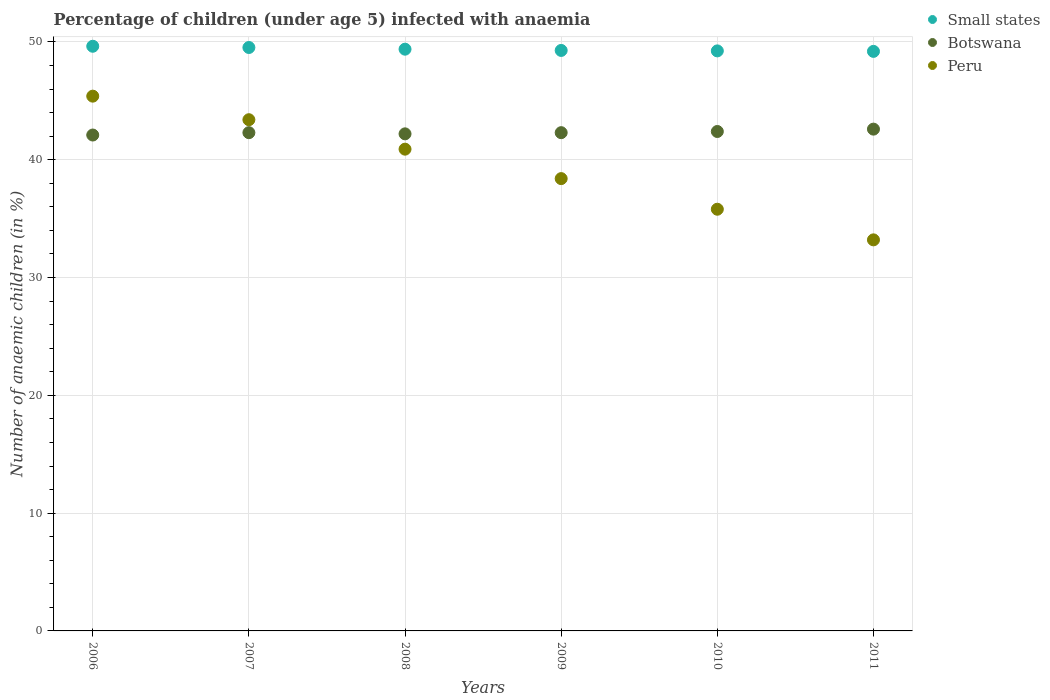What is the percentage of children infected with anaemia in in Small states in 2010?
Your answer should be compact. 49.24. Across all years, what is the maximum percentage of children infected with anaemia in in Botswana?
Ensure brevity in your answer.  42.6. Across all years, what is the minimum percentage of children infected with anaemia in in Botswana?
Your answer should be compact. 42.1. In which year was the percentage of children infected with anaemia in in Small states maximum?
Keep it short and to the point. 2006. In which year was the percentage of children infected with anaemia in in Botswana minimum?
Make the answer very short. 2006. What is the total percentage of children infected with anaemia in in Small states in the graph?
Keep it short and to the point. 296.28. What is the difference between the percentage of children infected with anaemia in in Peru in 2008 and the percentage of children infected with anaemia in in Small states in 2010?
Provide a short and direct response. -8.34. What is the average percentage of children infected with anaemia in in Small states per year?
Ensure brevity in your answer.  49.38. In the year 2007, what is the difference between the percentage of children infected with anaemia in in Small states and percentage of children infected with anaemia in in Botswana?
Provide a succinct answer. 7.23. In how many years, is the percentage of children infected with anaemia in in Small states greater than 40 %?
Make the answer very short. 6. What is the ratio of the percentage of children infected with anaemia in in Small states in 2007 to that in 2009?
Your answer should be very brief. 1.01. What is the difference between the highest and the second highest percentage of children infected with anaemia in in Small states?
Make the answer very short. 0.11. What is the difference between the highest and the lowest percentage of children infected with anaemia in in Peru?
Your answer should be very brief. 12.2. In how many years, is the percentage of children infected with anaemia in in Peru greater than the average percentage of children infected with anaemia in in Peru taken over all years?
Offer a terse response. 3. Is the sum of the percentage of children infected with anaemia in in Peru in 2006 and 2011 greater than the maximum percentage of children infected with anaemia in in Botswana across all years?
Provide a short and direct response. Yes. Does the percentage of children infected with anaemia in in Peru monotonically increase over the years?
Ensure brevity in your answer.  No. Is the percentage of children infected with anaemia in in Small states strictly greater than the percentage of children infected with anaemia in in Peru over the years?
Provide a succinct answer. Yes. Is the percentage of children infected with anaemia in in Small states strictly less than the percentage of children infected with anaemia in in Peru over the years?
Ensure brevity in your answer.  No. What is the difference between two consecutive major ticks on the Y-axis?
Keep it short and to the point. 10. Are the values on the major ticks of Y-axis written in scientific E-notation?
Your answer should be compact. No. Does the graph contain any zero values?
Offer a terse response. No. Where does the legend appear in the graph?
Provide a short and direct response. Top right. How many legend labels are there?
Keep it short and to the point. 3. How are the legend labels stacked?
Offer a terse response. Vertical. What is the title of the graph?
Your answer should be very brief. Percentage of children (under age 5) infected with anaemia. What is the label or title of the Y-axis?
Make the answer very short. Number of anaemic children (in %). What is the Number of anaemic children (in %) of Small states in 2006?
Your answer should be very brief. 49.64. What is the Number of anaemic children (in %) of Botswana in 2006?
Offer a very short reply. 42.1. What is the Number of anaemic children (in %) of Peru in 2006?
Offer a very short reply. 45.4. What is the Number of anaemic children (in %) in Small states in 2007?
Your answer should be very brief. 49.53. What is the Number of anaemic children (in %) in Botswana in 2007?
Provide a short and direct response. 42.3. What is the Number of anaemic children (in %) of Peru in 2007?
Provide a short and direct response. 43.4. What is the Number of anaemic children (in %) in Small states in 2008?
Make the answer very short. 49.39. What is the Number of anaemic children (in %) of Botswana in 2008?
Offer a terse response. 42.2. What is the Number of anaemic children (in %) of Peru in 2008?
Ensure brevity in your answer.  40.9. What is the Number of anaemic children (in %) of Small states in 2009?
Give a very brief answer. 49.28. What is the Number of anaemic children (in %) in Botswana in 2009?
Provide a succinct answer. 42.3. What is the Number of anaemic children (in %) in Peru in 2009?
Your answer should be very brief. 38.4. What is the Number of anaemic children (in %) of Small states in 2010?
Ensure brevity in your answer.  49.24. What is the Number of anaemic children (in %) in Botswana in 2010?
Your answer should be very brief. 42.4. What is the Number of anaemic children (in %) of Peru in 2010?
Provide a succinct answer. 35.8. What is the Number of anaemic children (in %) in Small states in 2011?
Your answer should be compact. 49.2. What is the Number of anaemic children (in %) in Botswana in 2011?
Offer a terse response. 42.6. What is the Number of anaemic children (in %) of Peru in 2011?
Give a very brief answer. 33.2. Across all years, what is the maximum Number of anaemic children (in %) in Small states?
Your answer should be compact. 49.64. Across all years, what is the maximum Number of anaemic children (in %) of Botswana?
Ensure brevity in your answer.  42.6. Across all years, what is the maximum Number of anaemic children (in %) in Peru?
Provide a short and direct response. 45.4. Across all years, what is the minimum Number of anaemic children (in %) in Small states?
Your response must be concise. 49.2. Across all years, what is the minimum Number of anaemic children (in %) in Botswana?
Give a very brief answer. 42.1. Across all years, what is the minimum Number of anaemic children (in %) in Peru?
Make the answer very short. 33.2. What is the total Number of anaemic children (in %) in Small states in the graph?
Your answer should be very brief. 296.28. What is the total Number of anaemic children (in %) of Botswana in the graph?
Ensure brevity in your answer.  253.9. What is the total Number of anaemic children (in %) in Peru in the graph?
Offer a very short reply. 237.1. What is the difference between the Number of anaemic children (in %) in Small states in 2006 and that in 2007?
Your answer should be compact. 0.11. What is the difference between the Number of anaemic children (in %) in Small states in 2006 and that in 2008?
Your response must be concise. 0.25. What is the difference between the Number of anaemic children (in %) of Botswana in 2006 and that in 2008?
Make the answer very short. -0.1. What is the difference between the Number of anaemic children (in %) in Peru in 2006 and that in 2008?
Make the answer very short. 4.5. What is the difference between the Number of anaemic children (in %) of Small states in 2006 and that in 2009?
Keep it short and to the point. 0.36. What is the difference between the Number of anaemic children (in %) in Botswana in 2006 and that in 2009?
Your answer should be very brief. -0.2. What is the difference between the Number of anaemic children (in %) in Peru in 2006 and that in 2009?
Your answer should be very brief. 7. What is the difference between the Number of anaemic children (in %) in Small states in 2006 and that in 2010?
Offer a terse response. 0.39. What is the difference between the Number of anaemic children (in %) in Peru in 2006 and that in 2010?
Give a very brief answer. 9.6. What is the difference between the Number of anaemic children (in %) in Small states in 2006 and that in 2011?
Your response must be concise. 0.44. What is the difference between the Number of anaemic children (in %) of Botswana in 2006 and that in 2011?
Provide a succinct answer. -0.5. What is the difference between the Number of anaemic children (in %) in Small states in 2007 and that in 2008?
Your answer should be very brief. 0.14. What is the difference between the Number of anaemic children (in %) of Peru in 2007 and that in 2008?
Keep it short and to the point. 2.5. What is the difference between the Number of anaemic children (in %) in Small states in 2007 and that in 2009?
Ensure brevity in your answer.  0.25. What is the difference between the Number of anaemic children (in %) in Small states in 2007 and that in 2010?
Offer a terse response. 0.29. What is the difference between the Number of anaemic children (in %) of Botswana in 2007 and that in 2010?
Make the answer very short. -0.1. What is the difference between the Number of anaemic children (in %) in Peru in 2007 and that in 2010?
Ensure brevity in your answer.  7.6. What is the difference between the Number of anaemic children (in %) in Small states in 2007 and that in 2011?
Give a very brief answer. 0.33. What is the difference between the Number of anaemic children (in %) of Botswana in 2007 and that in 2011?
Keep it short and to the point. -0.3. What is the difference between the Number of anaemic children (in %) of Small states in 2008 and that in 2009?
Provide a succinct answer. 0.11. What is the difference between the Number of anaemic children (in %) of Botswana in 2008 and that in 2009?
Provide a succinct answer. -0.1. What is the difference between the Number of anaemic children (in %) in Small states in 2008 and that in 2010?
Offer a terse response. 0.15. What is the difference between the Number of anaemic children (in %) of Botswana in 2008 and that in 2010?
Your answer should be compact. -0.2. What is the difference between the Number of anaemic children (in %) of Small states in 2008 and that in 2011?
Offer a terse response. 0.19. What is the difference between the Number of anaemic children (in %) in Botswana in 2008 and that in 2011?
Offer a very short reply. -0.4. What is the difference between the Number of anaemic children (in %) in Small states in 2009 and that in 2010?
Keep it short and to the point. 0.04. What is the difference between the Number of anaemic children (in %) in Small states in 2009 and that in 2011?
Make the answer very short. 0.08. What is the difference between the Number of anaemic children (in %) of Small states in 2010 and that in 2011?
Offer a very short reply. 0.04. What is the difference between the Number of anaemic children (in %) of Botswana in 2010 and that in 2011?
Give a very brief answer. -0.2. What is the difference between the Number of anaemic children (in %) of Small states in 2006 and the Number of anaemic children (in %) of Botswana in 2007?
Provide a succinct answer. 7.34. What is the difference between the Number of anaemic children (in %) of Small states in 2006 and the Number of anaemic children (in %) of Peru in 2007?
Give a very brief answer. 6.24. What is the difference between the Number of anaemic children (in %) of Small states in 2006 and the Number of anaemic children (in %) of Botswana in 2008?
Provide a short and direct response. 7.44. What is the difference between the Number of anaemic children (in %) of Small states in 2006 and the Number of anaemic children (in %) of Peru in 2008?
Give a very brief answer. 8.74. What is the difference between the Number of anaemic children (in %) of Small states in 2006 and the Number of anaemic children (in %) of Botswana in 2009?
Your response must be concise. 7.34. What is the difference between the Number of anaemic children (in %) of Small states in 2006 and the Number of anaemic children (in %) of Peru in 2009?
Keep it short and to the point. 11.24. What is the difference between the Number of anaemic children (in %) of Small states in 2006 and the Number of anaemic children (in %) of Botswana in 2010?
Give a very brief answer. 7.24. What is the difference between the Number of anaemic children (in %) of Small states in 2006 and the Number of anaemic children (in %) of Peru in 2010?
Make the answer very short. 13.84. What is the difference between the Number of anaemic children (in %) of Botswana in 2006 and the Number of anaemic children (in %) of Peru in 2010?
Your response must be concise. 6.3. What is the difference between the Number of anaemic children (in %) in Small states in 2006 and the Number of anaemic children (in %) in Botswana in 2011?
Keep it short and to the point. 7.04. What is the difference between the Number of anaemic children (in %) of Small states in 2006 and the Number of anaemic children (in %) of Peru in 2011?
Make the answer very short. 16.44. What is the difference between the Number of anaemic children (in %) in Botswana in 2006 and the Number of anaemic children (in %) in Peru in 2011?
Provide a short and direct response. 8.9. What is the difference between the Number of anaemic children (in %) in Small states in 2007 and the Number of anaemic children (in %) in Botswana in 2008?
Your answer should be compact. 7.33. What is the difference between the Number of anaemic children (in %) of Small states in 2007 and the Number of anaemic children (in %) of Peru in 2008?
Offer a terse response. 8.63. What is the difference between the Number of anaemic children (in %) of Botswana in 2007 and the Number of anaemic children (in %) of Peru in 2008?
Ensure brevity in your answer.  1.4. What is the difference between the Number of anaemic children (in %) of Small states in 2007 and the Number of anaemic children (in %) of Botswana in 2009?
Your answer should be very brief. 7.23. What is the difference between the Number of anaemic children (in %) of Small states in 2007 and the Number of anaemic children (in %) of Peru in 2009?
Make the answer very short. 11.13. What is the difference between the Number of anaemic children (in %) in Small states in 2007 and the Number of anaemic children (in %) in Botswana in 2010?
Make the answer very short. 7.13. What is the difference between the Number of anaemic children (in %) of Small states in 2007 and the Number of anaemic children (in %) of Peru in 2010?
Make the answer very short. 13.73. What is the difference between the Number of anaemic children (in %) in Small states in 2007 and the Number of anaemic children (in %) in Botswana in 2011?
Your response must be concise. 6.93. What is the difference between the Number of anaemic children (in %) of Small states in 2007 and the Number of anaemic children (in %) of Peru in 2011?
Your answer should be compact. 16.33. What is the difference between the Number of anaemic children (in %) of Botswana in 2007 and the Number of anaemic children (in %) of Peru in 2011?
Your answer should be compact. 9.1. What is the difference between the Number of anaemic children (in %) in Small states in 2008 and the Number of anaemic children (in %) in Botswana in 2009?
Keep it short and to the point. 7.09. What is the difference between the Number of anaemic children (in %) in Small states in 2008 and the Number of anaemic children (in %) in Peru in 2009?
Your answer should be very brief. 10.99. What is the difference between the Number of anaemic children (in %) of Small states in 2008 and the Number of anaemic children (in %) of Botswana in 2010?
Your answer should be compact. 6.99. What is the difference between the Number of anaemic children (in %) of Small states in 2008 and the Number of anaemic children (in %) of Peru in 2010?
Make the answer very short. 13.59. What is the difference between the Number of anaemic children (in %) in Botswana in 2008 and the Number of anaemic children (in %) in Peru in 2010?
Provide a succinct answer. 6.4. What is the difference between the Number of anaemic children (in %) in Small states in 2008 and the Number of anaemic children (in %) in Botswana in 2011?
Provide a succinct answer. 6.79. What is the difference between the Number of anaemic children (in %) in Small states in 2008 and the Number of anaemic children (in %) in Peru in 2011?
Provide a short and direct response. 16.19. What is the difference between the Number of anaemic children (in %) in Botswana in 2008 and the Number of anaemic children (in %) in Peru in 2011?
Give a very brief answer. 9. What is the difference between the Number of anaemic children (in %) of Small states in 2009 and the Number of anaemic children (in %) of Botswana in 2010?
Offer a terse response. 6.88. What is the difference between the Number of anaemic children (in %) in Small states in 2009 and the Number of anaemic children (in %) in Peru in 2010?
Provide a succinct answer. 13.48. What is the difference between the Number of anaemic children (in %) of Botswana in 2009 and the Number of anaemic children (in %) of Peru in 2010?
Ensure brevity in your answer.  6.5. What is the difference between the Number of anaemic children (in %) in Small states in 2009 and the Number of anaemic children (in %) in Botswana in 2011?
Provide a succinct answer. 6.68. What is the difference between the Number of anaemic children (in %) in Small states in 2009 and the Number of anaemic children (in %) in Peru in 2011?
Keep it short and to the point. 16.08. What is the difference between the Number of anaemic children (in %) in Small states in 2010 and the Number of anaemic children (in %) in Botswana in 2011?
Keep it short and to the point. 6.64. What is the difference between the Number of anaemic children (in %) in Small states in 2010 and the Number of anaemic children (in %) in Peru in 2011?
Provide a short and direct response. 16.04. What is the average Number of anaemic children (in %) of Small states per year?
Make the answer very short. 49.38. What is the average Number of anaemic children (in %) of Botswana per year?
Keep it short and to the point. 42.32. What is the average Number of anaemic children (in %) in Peru per year?
Give a very brief answer. 39.52. In the year 2006, what is the difference between the Number of anaemic children (in %) of Small states and Number of anaemic children (in %) of Botswana?
Your answer should be very brief. 7.54. In the year 2006, what is the difference between the Number of anaemic children (in %) in Small states and Number of anaemic children (in %) in Peru?
Provide a short and direct response. 4.24. In the year 2006, what is the difference between the Number of anaemic children (in %) of Botswana and Number of anaemic children (in %) of Peru?
Offer a terse response. -3.3. In the year 2007, what is the difference between the Number of anaemic children (in %) in Small states and Number of anaemic children (in %) in Botswana?
Offer a very short reply. 7.23. In the year 2007, what is the difference between the Number of anaemic children (in %) of Small states and Number of anaemic children (in %) of Peru?
Offer a very short reply. 6.13. In the year 2007, what is the difference between the Number of anaemic children (in %) in Botswana and Number of anaemic children (in %) in Peru?
Provide a short and direct response. -1.1. In the year 2008, what is the difference between the Number of anaemic children (in %) of Small states and Number of anaemic children (in %) of Botswana?
Offer a terse response. 7.19. In the year 2008, what is the difference between the Number of anaemic children (in %) in Small states and Number of anaemic children (in %) in Peru?
Provide a succinct answer. 8.49. In the year 2009, what is the difference between the Number of anaemic children (in %) of Small states and Number of anaemic children (in %) of Botswana?
Offer a very short reply. 6.98. In the year 2009, what is the difference between the Number of anaemic children (in %) of Small states and Number of anaemic children (in %) of Peru?
Keep it short and to the point. 10.88. In the year 2010, what is the difference between the Number of anaemic children (in %) of Small states and Number of anaemic children (in %) of Botswana?
Offer a terse response. 6.84. In the year 2010, what is the difference between the Number of anaemic children (in %) of Small states and Number of anaemic children (in %) of Peru?
Provide a short and direct response. 13.44. In the year 2010, what is the difference between the Number of anaemic children (in %) of Botswana and Number of anaemic children (in %) of Peru?
Your response must be concise. 6.6. In the year 2011, what is the difference between the Number of anaemic children (in %) of Small states and Number of anaemic children (in %) of Botswana?
Your answer should be compact. 6.6. In the year 2011, what is the difference between the Number of anaemic children (in %) of Small states and Number of anaemic children (in %) of Peru?
Your answer should be very brief. 16. What is the ratio of the Number of anaemic children (in %) in Peru in 2006 to that in 2007?
Make the answer very short. 1.05. What is the ratio of the Number of anaemic children (in %) of Botswana in 2006 to that in 2008?
Ensure brevity in your answer.  1. What is the ratio of the Number of anaemic children (in %) in Peru in 2006 to that in 2008?
Offer a terse response. 1.11. What is the ratio of the Number of anaemic children (in %) in Botswana in 2006 to that in 2009?
Give a very brief answer. 1. What is the ratio of the Number of anaemic children (in %) in Peru in 2006 to that in 2009?
Offer a very short reply. 1.18. What is the ratio of the Number of anaemic children (in %) in Small states in 2006 to that in 2010?
Your answer should be very brief. 1.01. What is the ratio of the Number of anaemic children (in %) of Botswana in 2006 to that in 2010?
Your answer should be very brief. 0.99. What is the ratio of the Number of anaemic children (in %) in Peru in 2006 to that in 2010?
Your answer should be compact. 1.27. What is the ratio of the Number of anaemic children (in %) in Small states in 2006 to that in 2011?
Provide a short and direct response. 1.01. What is the ratio of the Number of anaemic children (in %) of Botswana in 2006 to that in 2011?
Your answer should be compact. 0.99. What is the ratio of the Number of anaemic children (in %) in Peru in 2006 to that in 2011?
Provide a short and direct response. 1.37. What is the ratio of the Number of anaemic children (in %) of Peru in 2007 to that in 2008?
Provide a succinct answer. 1.06. What is the ratio of the Number of anaemic children (in %) of Small states in 2007 to that in 2009?
Provide a short and direct response. 1.01. What is the ratio of the Number of anaemic children (in %) of Botswana in 2007 to that in 2009?
Your answer should be very brief. 1. What is the ratio of the Number of anaemic children (in %) in Peru in 2007 to that in 2009?
Keep it short and to the point. 1.13. What is the ratio of the Number of anaemic children (in %) in Peru in 2007 to that in 2010?
Offer a very short reply. 1.21. What is the ratio of the Number of anaemic children (in %) in Small states in 2007 to that in 2011?
Offer a very short reply. 1.01. What is the ratio of the Number of anaemic children (in %) of Peru in 2007 to that in 2011?
Ensure brevity in your answer.  1.31. What is the ratio of the Number of anaemic children (in %) in Peru in 2008 to that in 2009?
Your answer should be very brief. 1.07. What is the ratio of the Number of anaemic children (in %) in Botswana in 2008 to that in 2010?
Keep it short and to the point. 1. What is the ratio of the Number of anaemic children (in %) in Peru in 2008 to that in 2010?
Make the answer very short. 1.14. What is the ratio of the Number of anaemic children (in %) in Small states in 2008 to that in 2011?
Your answer should be compact. 1. What is the ratio of the Number of anaemic children (in %) of Botswana in 2008 to that in 2011?
Provide a succinct answer. 0.99. What is the ratio of the Number of anaemic children (in %) of Peru in 2008 to that in 2011?
Keep it short and to the point. 1.23. What is the ratio of the Number of anaemic children (in %) in Small states in 2009 to that in 2010?
Your response must be concise. 1. What is the ratio of the Number of anaemic children (in %) of Botswana in 2009 to that in 2010?
Offer a terse response. 1. What is the ratio of the Number of anaemic children (in %) in Peru in 2009 to that in 2010?
Your answer should be very brief. 1.07. What is the ratio of the Number of anaemic children (in %) of Small states in 2009 to that in 2011?
Offer a very short reply. 1. What is the ratio of the Number of anaemic children (in %) in Peru in 2009 to that in 2011?
Offer a very short reply. 1.16. What is the ratio of the Number of anaemic children (in %) of Small states in 2010 to that in 2011?
Your answer should be very brief. 1. What is the ratio of the Number of anaemic children (in %) in Botswana in 2010 to that in 2011?
Your response must be concise. 1. What is the ratio of the Number of anaemic children (in %) in Peru in 2010 to that in 2011?
Ensure brevity in your answer.  1.08. What is the difference between the highest and the second highest Number of anaemic children (in %) of Small states?
Give a very brief answer. 0.11. What is the difference between the highest and the second highest Number of anaemic children (in %) in Botswana?
Provide a succinct answer. 0.2. What is the difference between the highest and the lowest Number of anaemic children (in %) of Small states?
Offer a very short reply. 0.44. 